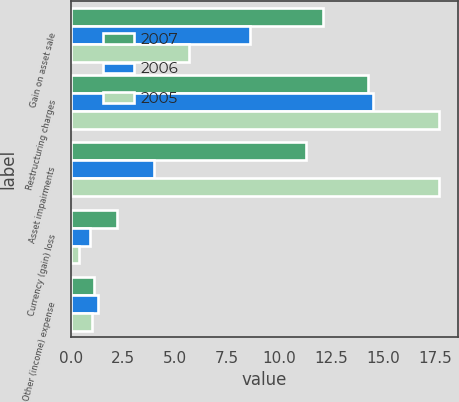Convert chart to OTSL. <chart><loc_0><loc_0><loc_500><loc_500><stacked_bar_chart><ecel><fcel>Gain on asset sale<fcel>Restructuring charges<fcel>Asset impairments<fcel>Currency (gain) loss<fcel>Other (income) expense<nl><fcel>2007<fcel>12.1<fcel>14.3<fcel>11.3<fcel>2.2<fcel>1.1<nl><fcel>2006<fcel>8.6<fcel>14.5<fcel>4<fcel>0.9<fcel>1.3<nl><fcel>2005<fcel>5.7<fcel>17.7<fcel>17.7<fcel>0.4<fcel>1<nl></chart> 